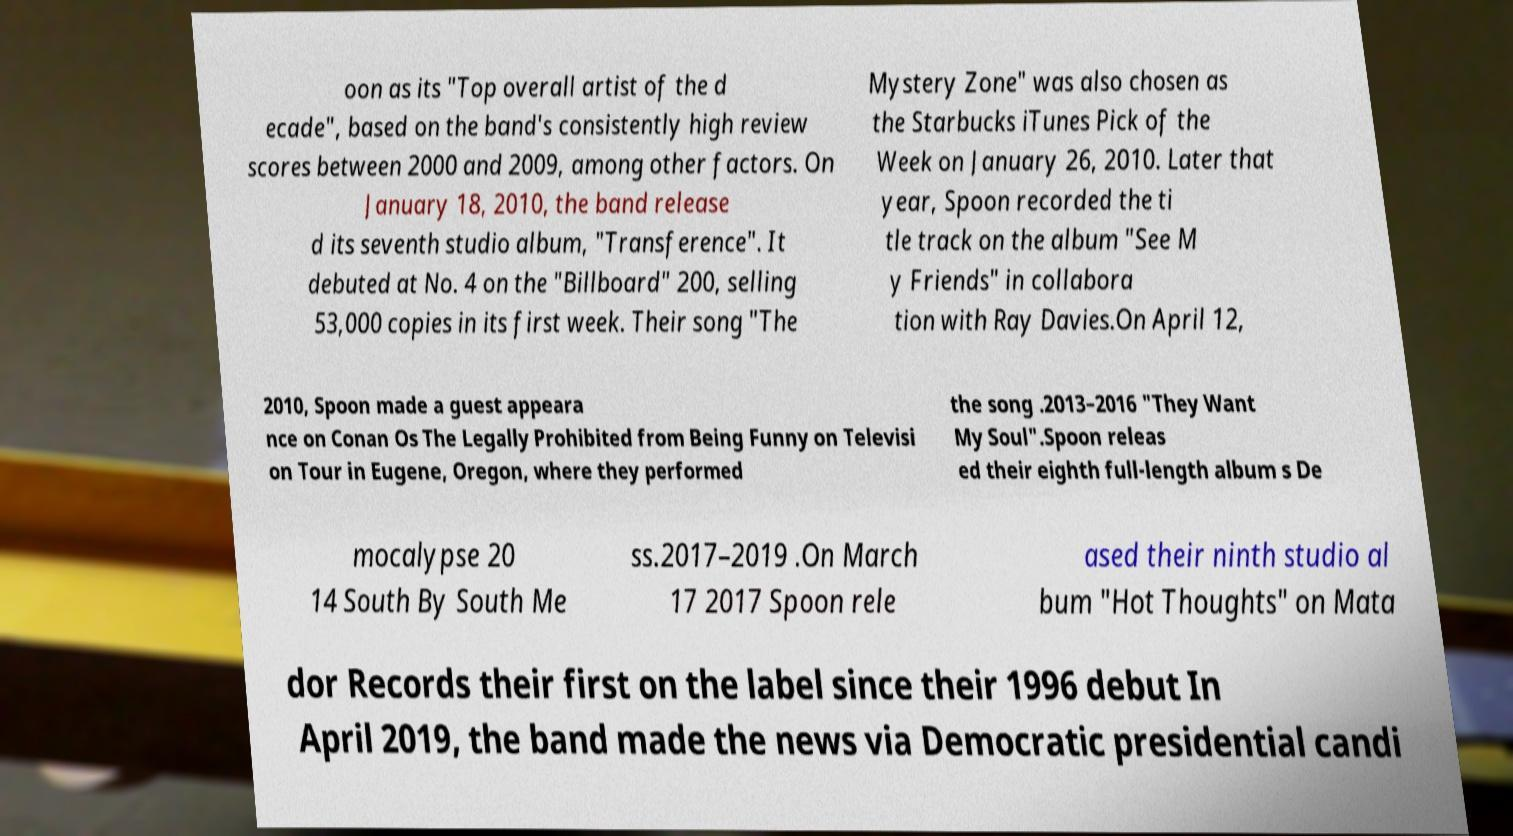Could you assist in decoding the text presented in this image and type it out clearly? oon as its "Top overall artist of the d ecade", based on the band's consistently high review scores between 2000 and 2009, among other factors. On January 18, 2010, the band release d its seventh studio album, "Transference". It debuted at No. 4 on the "Billboard" 200, selling 53,000 copies in its first week. Their song "The Mystery Zone" was also chosen as the Starbucks iTunes Pick of the Week on January 26, 2010. Later that year, Spoon recorded the ti tle track on the album "See M y Friends" in collabora tion with Ray Davies.On April 12, 2010, Spoon made a guest appeara nce on Conan Os The Legally Prohibited from Being Funny on Televisi on Tour in Eugene, Oregon, where they performed the song .2013–2016 "They Want My Soul".Spoon releas ed their eighth full-length album s De mocalypse 20 14 South By South Me ss.2017–2019 .On March 17 2017 Spoon rele ased their ninth studio al bum "Hot Thoughts" on Mata dor Records their first on the label since their 1996 debut In April 2019, the band made the news via Democratic presidential candi 